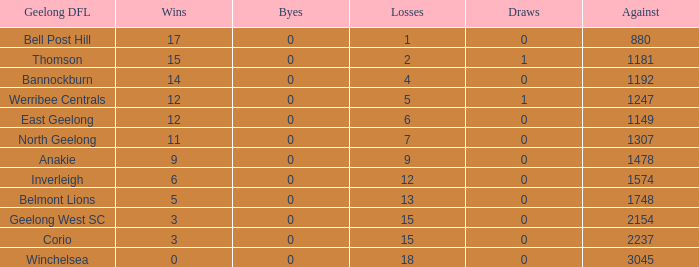What is the maximum number of byes when there were 9 losses and the draws were negative? None. 